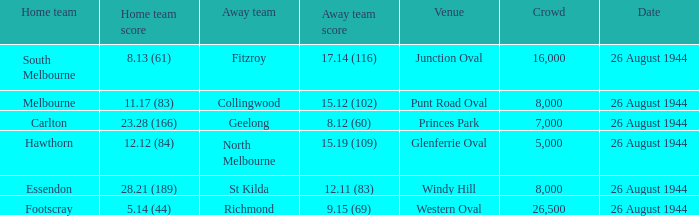Which location is the one for the footscray home team? Western Oval. 